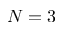<formula> <loc_0><loc_0><loc_500><loc_500>N = 3</formula> 